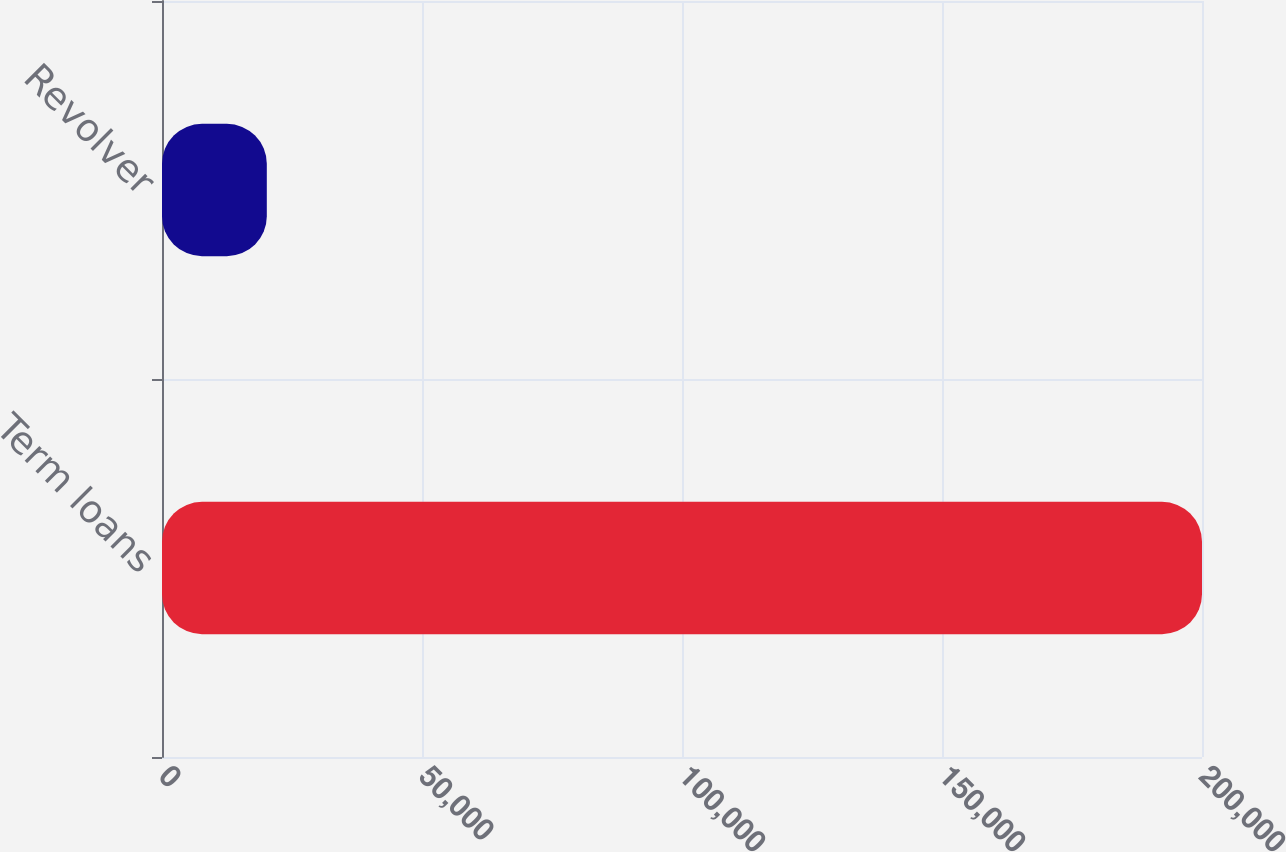Convert chart to OTSL. <chart><loc_0><loc_0><loc_500><loc_500><bar_chart><fcel>Term loans<fcel>Revolver<nl><fcel>200000<fcel>20156<nl></chart> 